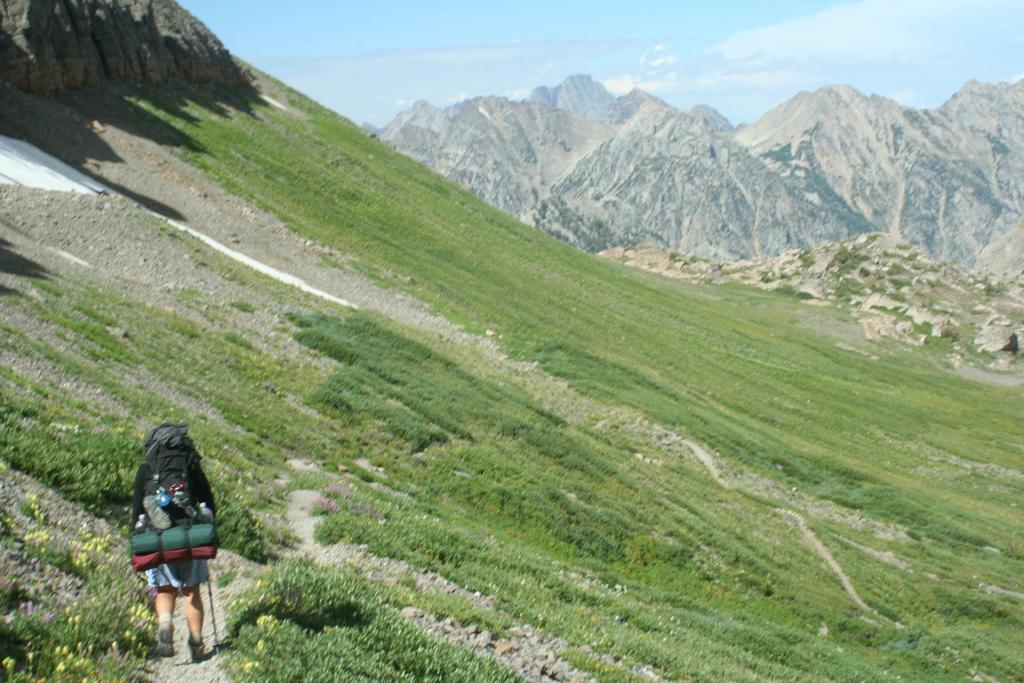Could you give a brief overview of what you see in this image? In this image I can see a person is standing and carrying a bag and other objects. In the background I can see mountains, the grass and the sky. 